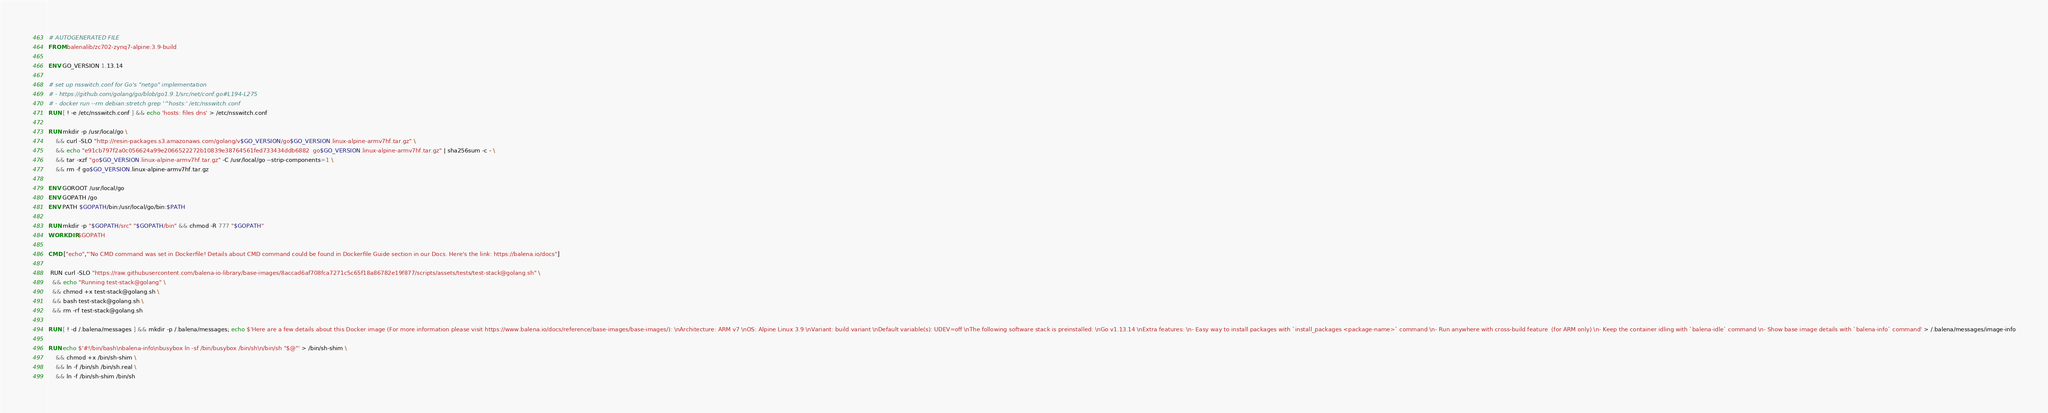<code> <loc_0><loc_0><loc_500><loc_500><_Dockerfile_># AUTOGENERATED FILE
FROM balenalib/zc702-zynq7-alpine:3.9-build

ENV GO_VERSION 1.13.14

# set up nsswitch.conf for Go's "netgo" implementation
# - https://github.com/golang/go/blob/go1.9.1/src/net/conf.go#L194-L275
# - docker run --rm debian:stretch grep '^hosts:' /etc/nsswitch.conf
RUN [ ! -e /etc/nsswitch.conf ] && echo 'hosts: files dns' > /etc/nsswitch.conf

RUN mkdir -p /usr/local/go \
	&& curl -SLO "http://resin-packages.s3.amazonaws.com/golang/v$GO_VERSION/go$GO_VERSION.linux-alpine-armv7hf.tar.gz" \
	&& echo "e91cb797f2a0c056624a99e2066522272b10839e38764561fed733434ddb6882  go$GO_VERSION.linux-alpine-armv7hf.tar.gz" | sha256sum -c - \
	&& tar -xzf "go$GO_VERSION.linux-alpine-armv7hf.tar.gz" -C /usr/local/go --strip-components=1 \
	&& rm -f go$GO_VERSION.linux-alpine-armv7hf.tar.gz

ENV GOROOT /usr/local/go
ENV GOPATH /go
ENV PATH $GOPATH/bin:/usr/local/go/bin:$PATH

RUN mkdir -p "$GOPATH/src" "$GOPATH/bin" && chmod -R 777 "$GOPATH"
WORKDIR $GOPATH

CMD ["echo","'No CMD command was set in Dockerfile! Details about CMD command could be found in Dockerfile Guide section in our Docs. Here's the link: https://balena.io/docs"]

 RUN curl -SLO "https://raw.githubusercontent.com/balena-io-library/base-images/8accad6af708fca7271c5c65f18a86782e19f877/scripts/assets/tests/test-stack@golang.sh" \
  && echo "Running test-stack@golang" \
  && chmod +x test-stack@golang.sh \
  && bash test-stack@golang.sh \
  && rm -rf test-stack@golang.sh 

RUN [ ! -d /.balena/messages ] && mkdir -p /.balena/messages; echo $'Here are a few details about this Docker image (For more information please visit https://www.balena.io/docs/reference/base-images/base-images/): \nArchitecture: ARM v7 \nOS: Alpine Linux 3.9 \nVariant: build variant \nDefault variable(s): UDEV=off \nThe following software stack is preinstalled: \nGo v1.13.14 \nExtra features: \n- Easy way to install packages with `install_packages <package-name>` command \n- Run anywhere with cross-build feature  (for ARM only) \n- Keep the container idling with `balena-idle` command \n- Show base image details with `balena-info` command' > /.balena/messages/image-info

RUN echo $'#!/bin/bash\nbalena-info\nbusybox ln -sf /bin/busybox /bin/sh\n/bin/sh "$@"' > /bin/sh-shim \
	&& chmod +x /bin/sh-shim \
	&& ln -f /bin/sh /bin/sh.real \
	&& ln -f /bin/sh-shim /bin/sh</code> 